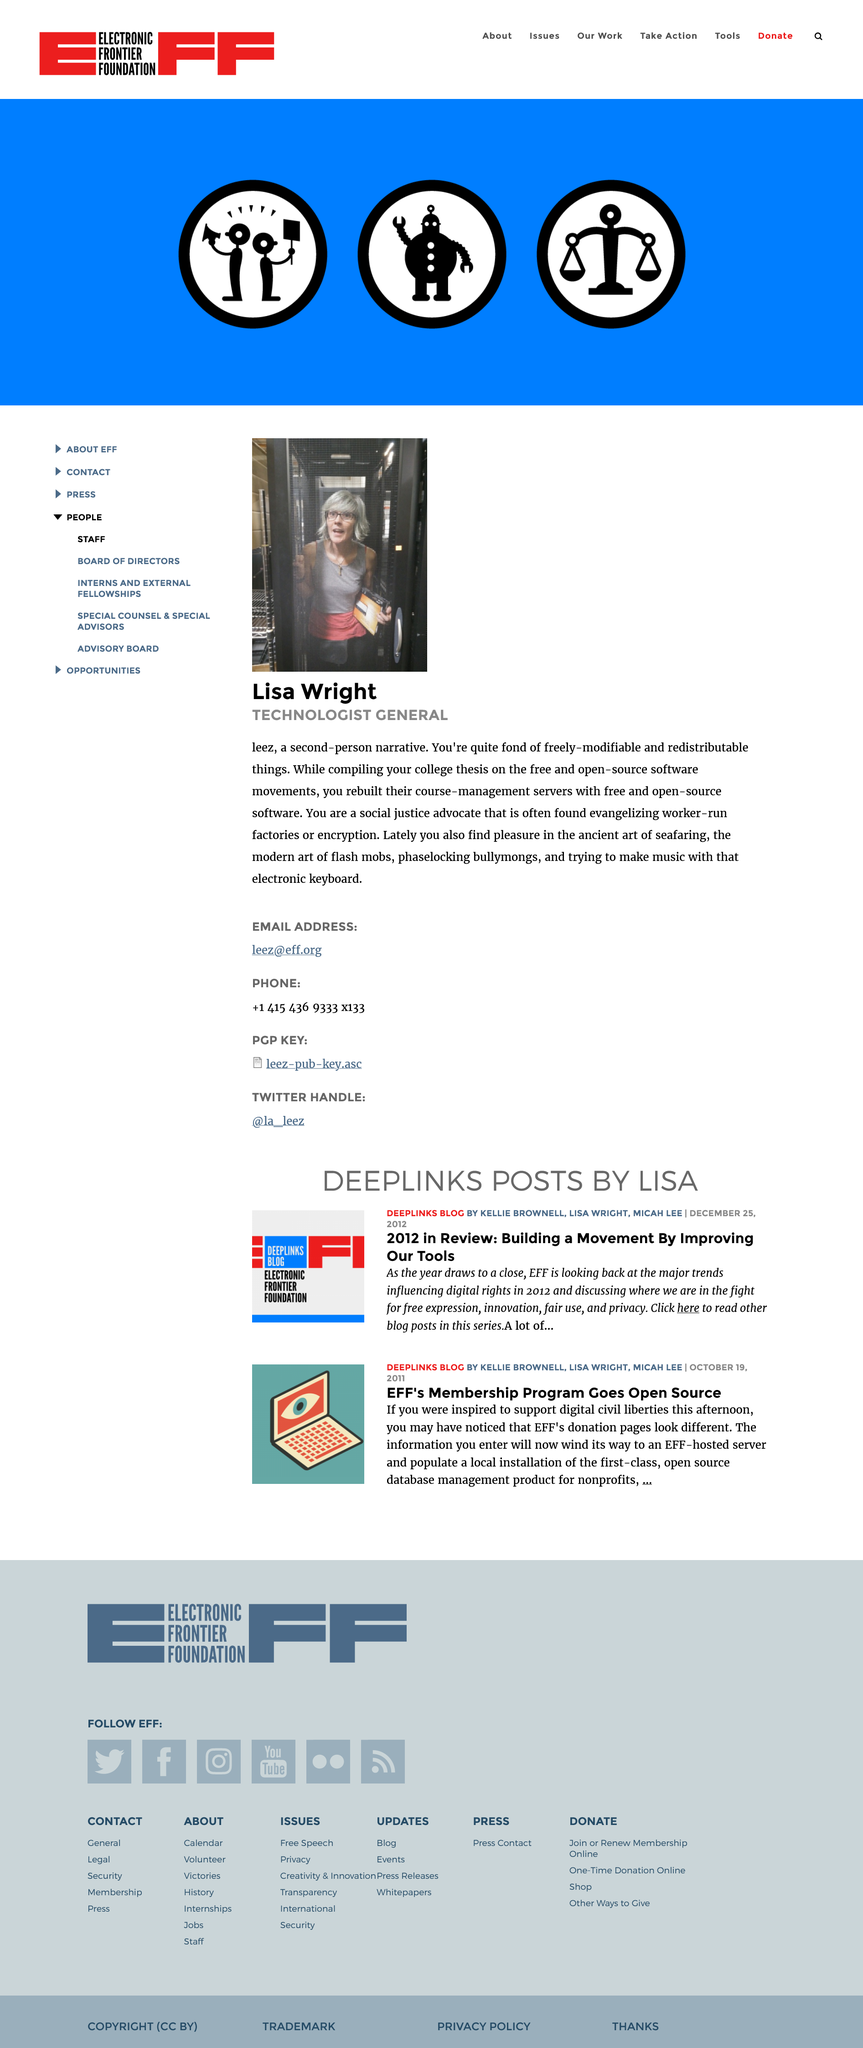Specify some key components in this picture. This page is a biography of a person or thing. Lisa's role is that of a technologist general. The second-person narrative reveals that the course-management servers were rebuilt using free and open-source software. 